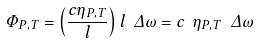<formula> <loc_0><loc_0><loc_500><loc_500>\Phi _ { P , T } = \left ( \frac { c \eta _ { P , T } } { l } \right ) l \ \Delta \omega = c \ \eta _ { P , T } \ \Delta \omega</formula> 